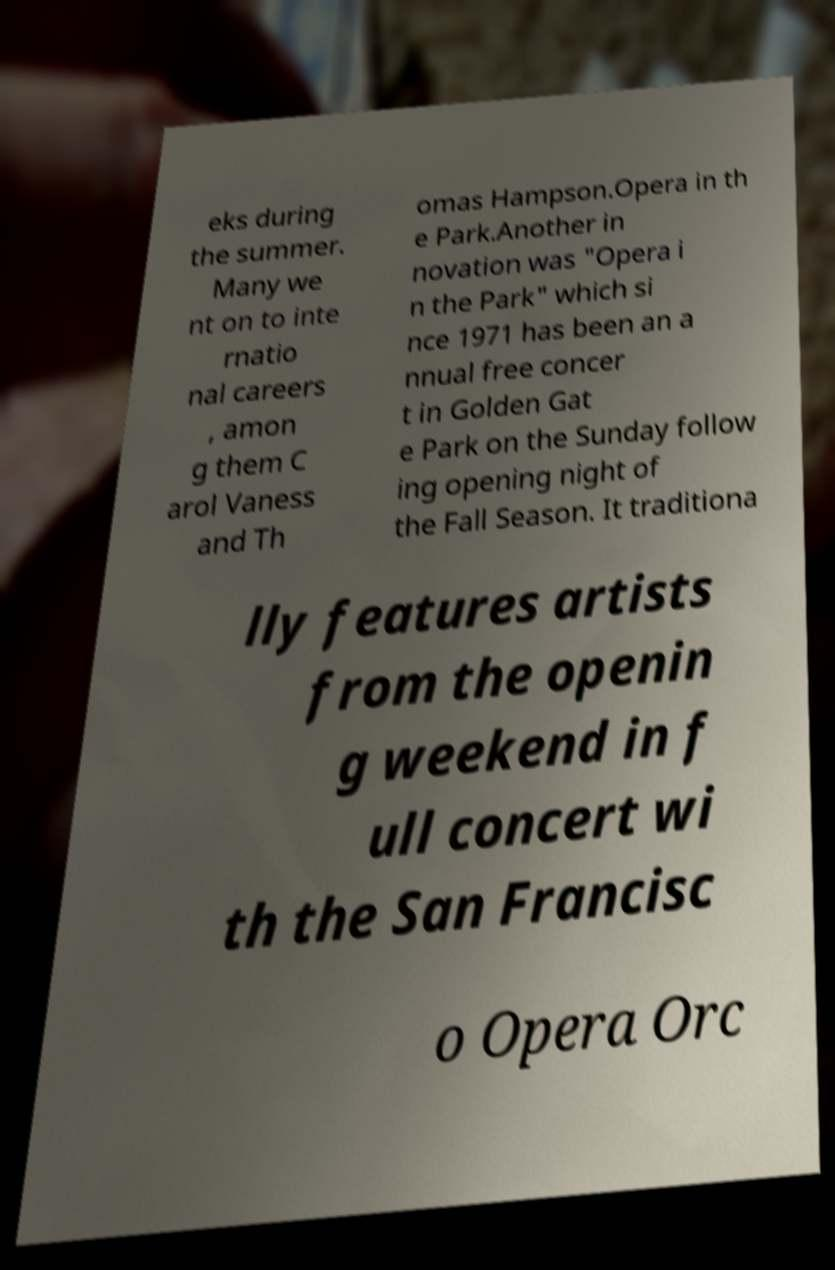Could you assist in decoding the text presented in this image and type it out clearly? eks during the summer. Many we nt on to inte rnatio nal careers , amon g them C arol Vaness and Th omas Hampson.Opera in th e Park.Another in novation was "Opera i n the Park" which si nce 1971 has been an a nnual free concer t in Golden Gat e Park on the Sunday follow ing opening night of the Fall Season. It traditiona lly features artists from the openin g weekend in f ull concert wi th the San Francisc o Opera Orc 